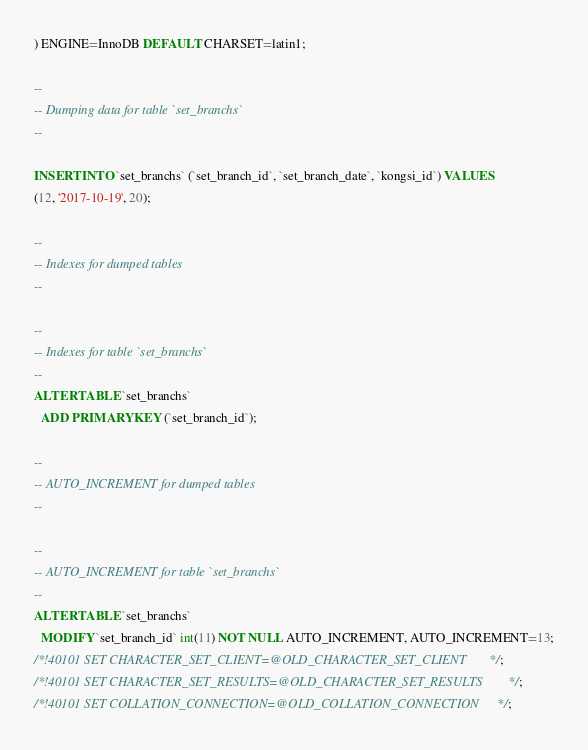Convert code to text. <code><loc_0><loc_0><loc_500><loc_500><_SQL_>) ENGINE=InnoDB DEFAULT CHARSET=latin1;

--
-- Dumping data for table `set_branchs`
--

INSERT INTO `set_branchs` (`set_branch_id`, `set_branch_date`, `kongsi_id`) VALUES
(12, '2017-10-19', 20);

--
-- Indexes for dumped tables
--

--
-- Indexes for table `set_branchs`
--
ALTER TABLE `set_branchs`
  ADD PRIMARY KEY (`set_branch_id`);

--
-- AUTO_INCREMENT for dumped tables
--

--
-- AUTO_INCREMENT for table `set_branchs`
--
ALTER TABLE `set_branchs`
  MODIFY `set_branch_id` int(11) NOT NULL AUTO_INCREMENT, AUTO_INCREMENT=13;
/*!40101 SET CHARACTER_SET_CLIENT=@OLD_CHARACTER_SET_CLIENT */;
/*!40101 SET CHARACTER_SET_RESULTS=@OLD_CHARACTER_SET_RESULTS */;
/*!40101 SET COLLATION_CONNECTION=@OLD_COLLATION_CONNECTION */;
</code> 